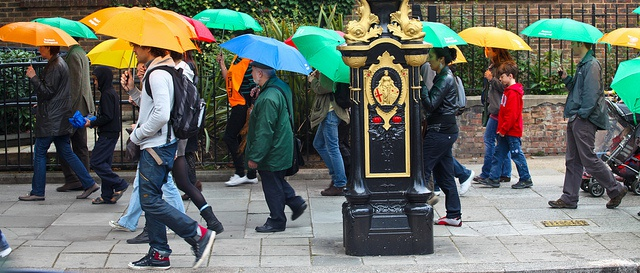Describe the objects in this image and their specific colors. I can see people in black, lightgray, navy, and blue tones, people in black, teal, navy, and gray tones, people in black, gray, and blue tones, people in black, navy, gray, and maroon tones, and people in black, navy, gray, and blue tones in this image. 